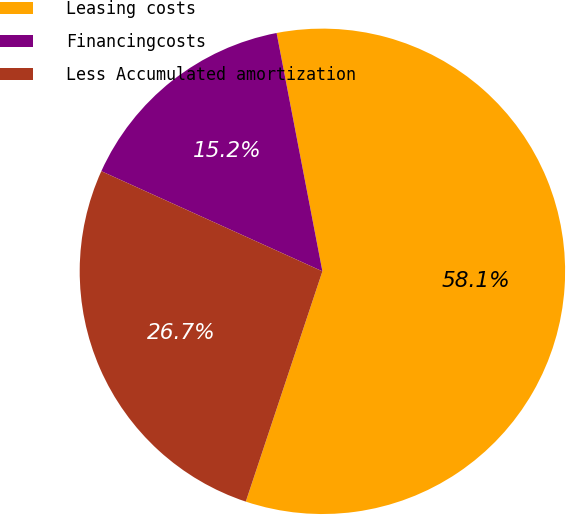<chart> <loc_0><loc_0><loc_500><loc_500><pie_chart><fcel>Leasing costs<fcel>Financingcosts<fcel>Less Accumulated amortization<nl><fcel>58.14%<fcel>15.21%<fcel>26.66%<nl></chart> 